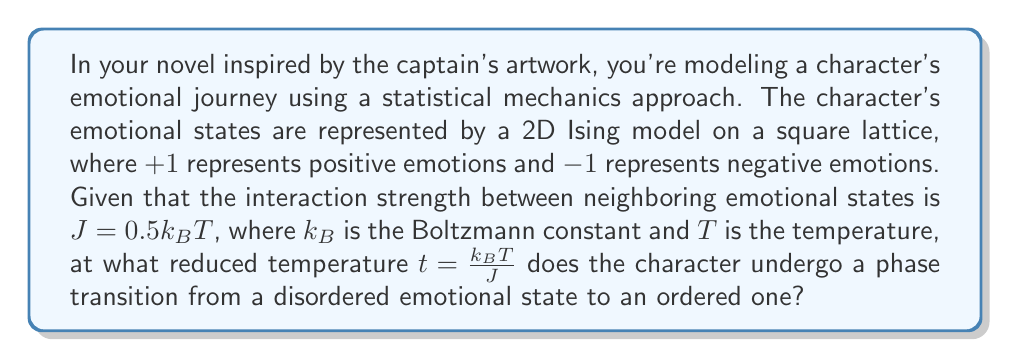Can you answer this question? To solve this problem, we'll follow these steps:

1) The 2D Ising model on a square lattice is known to have an exact solution for its critical temperature, derived by Onsager.

2) The critical temperature for the 2D Ising model is given by:

   $$\frac{k_BT_c}{J} = \frac{2}{\ln(1+\sqrt{2})} \approx 2.269$$

3) In our case, we're given that $J = 0.5k_BT$. Let's substitute this into the critical temperature equation:

   $$\frac{k_BT_c}{0.5k_BT_c} = \frac{2}{\ln(1+\sqrt{2})}$$

4) Simplify:

   $$2 = \frac{2}{\ln(1+\sqrt{2})}$$

5) This equation is already satisfied, which means that the critical reduced temperature $t_c$ is:

   $$t_c = \frac{k_BT_c}{J} = 2$$

6) At this temperature, the character's emotional state will undergo a phase transition from a disordered (random mix of positive and negative emotions) to an ordered state (predominantly positive or negative emotions).
Answer: $t_c = 2$ 